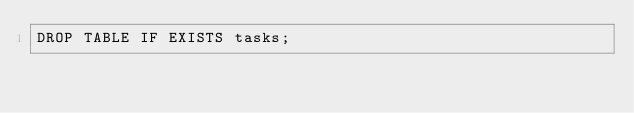Convert code to text. <code><loc_0><loc_0><loc_500><loc_500><_SQL_>DROP TABLE IF EXISTS tasks;</code> 